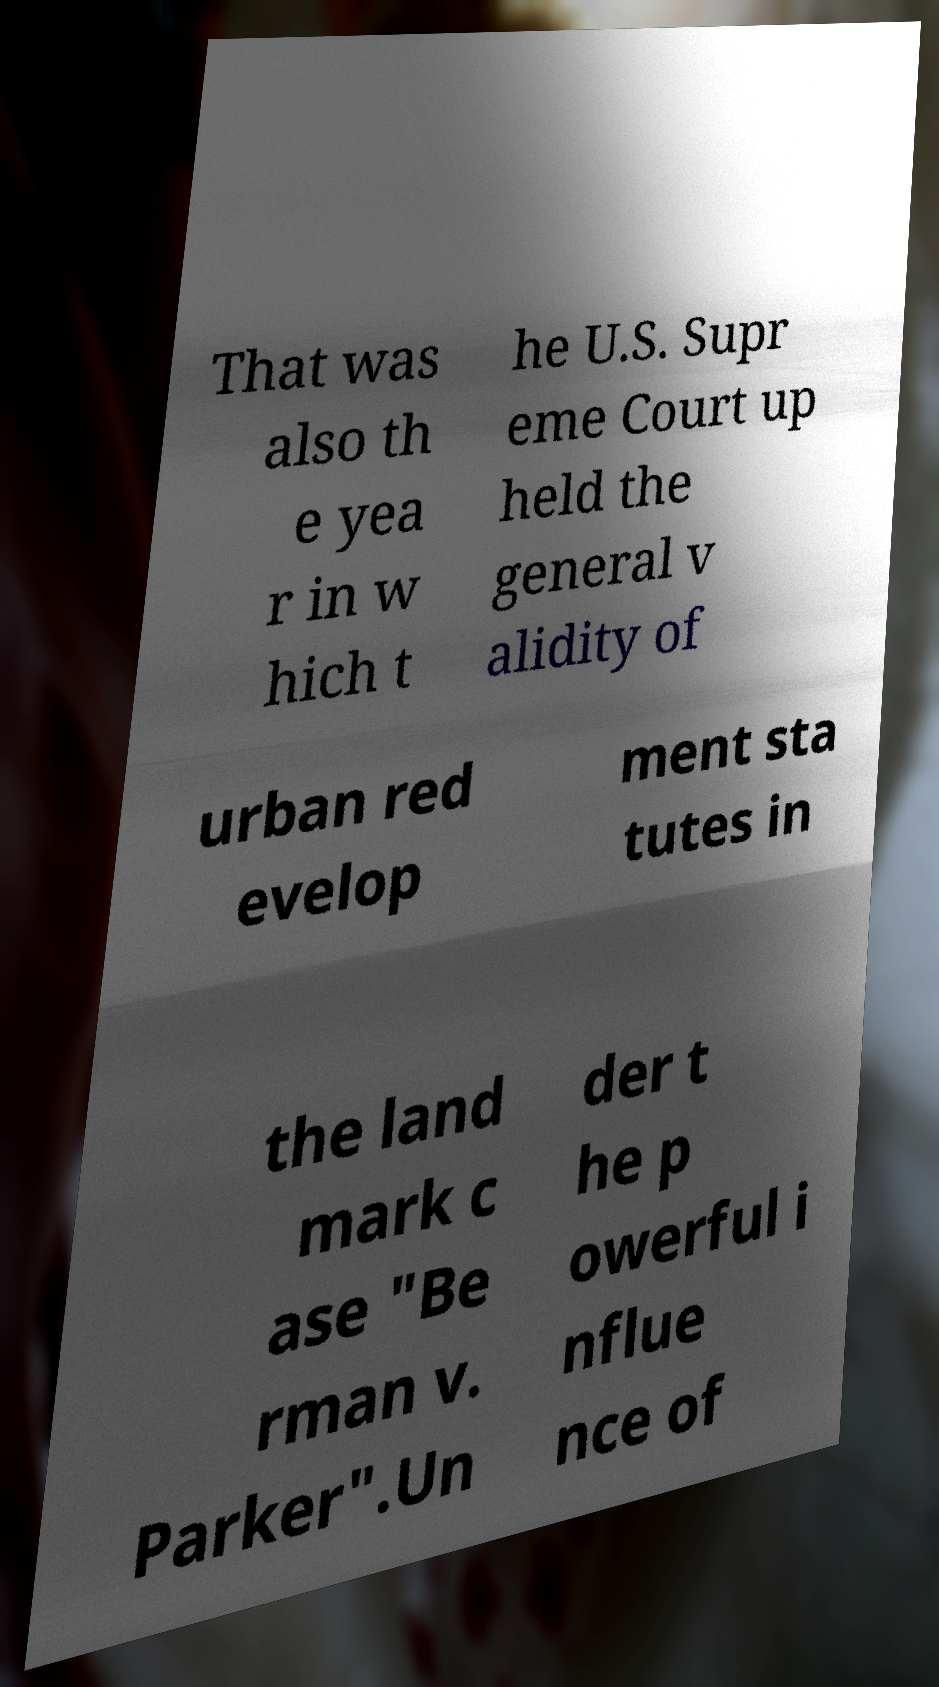Can you accurately transcribe the text from the provided image for me? That was also th e yea r in w hich t he U.S. Supr eme Court up held the general v alidity of urban red evelop ment sta tutes in the land mark c ase "Be rman v. Parker".Un der t he p owerful i nflue nce of 